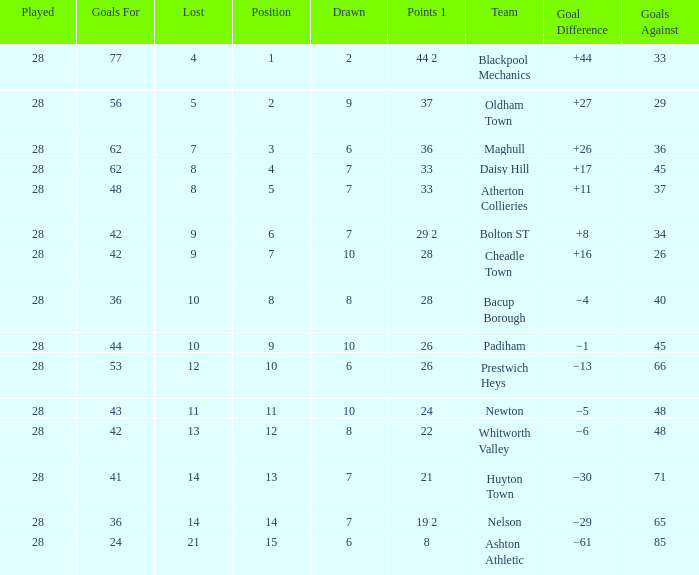What is the average played for entries with fewer than 65 goals against, points 1 of 19 2, and a position higher than 15? None. 